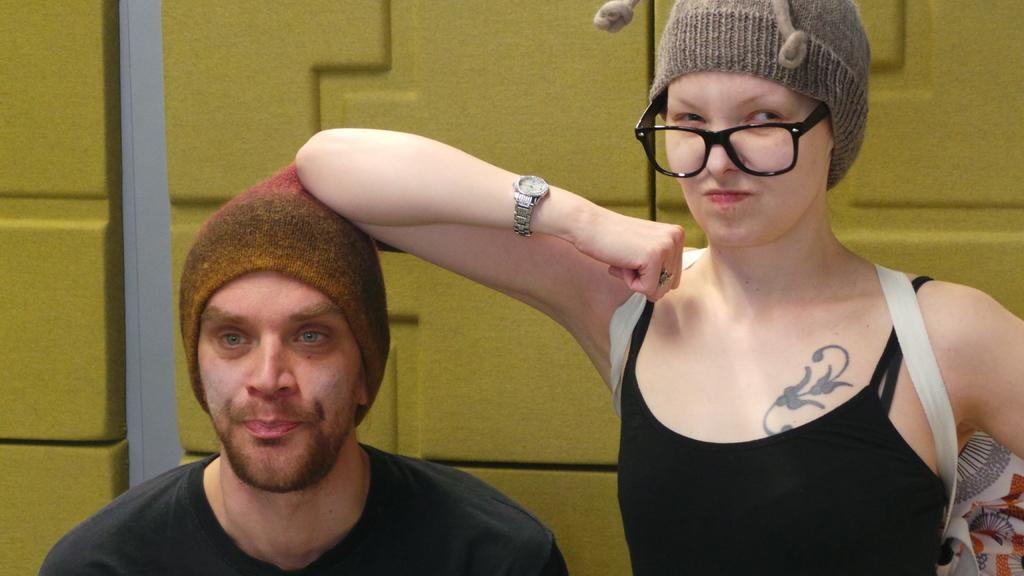How many people are in the image? There are two persons in the image. What can be observed about the woman's appearance? The woman is wearing spectacles and a cap. What is the woman carrying on her back? The woman has a backpack. Where is the backpack located in the image? The backpack is visible on the right side of the image. What is the color of the wall in the background of the image? There is a green color wall in the background of the image. What type of paste is being used by the woman in the image? There is no indication in the image that the woman is using any paste. 